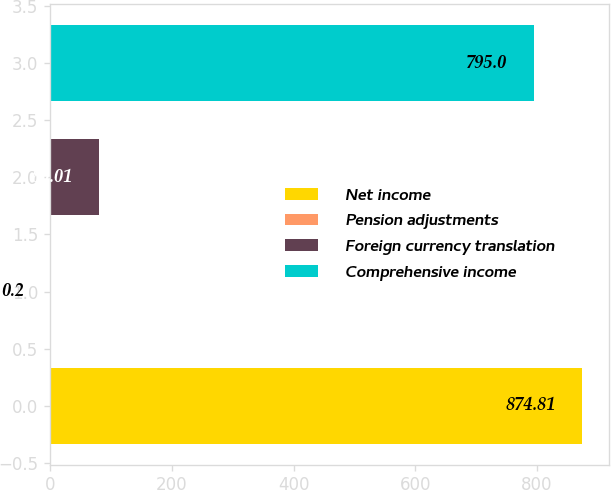Convert chart to OTSL. <chart><loc_0><loc_0><loc_500><loc_500><bar_chart><fcel>Net income<fcel>Pension adjustments<fcel>Foreign currency translation<fcel>Comprehensive income<nl><fcel>874.81<fcel>0.2<fcel>80.01<fcel>795<nl></chart> 